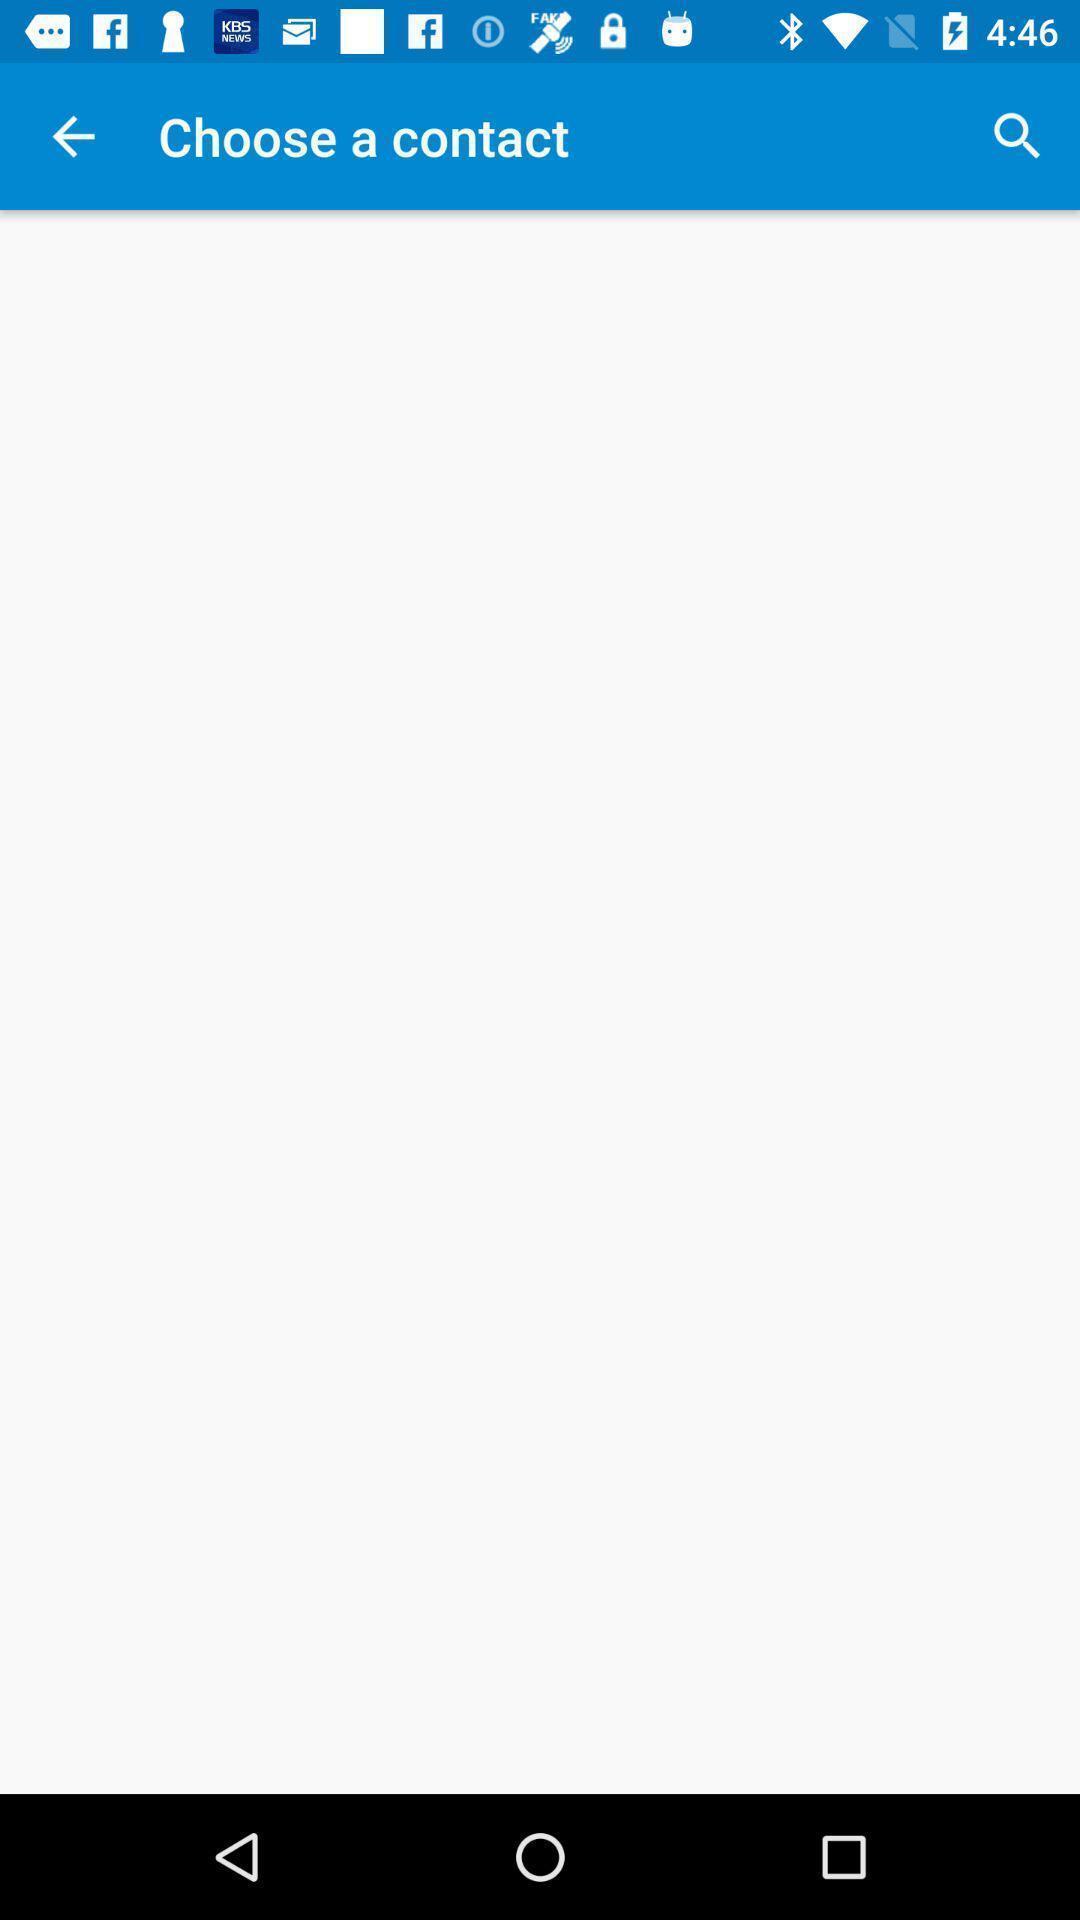Tell me what you see in this picture. Screen shows to choose a contact. 